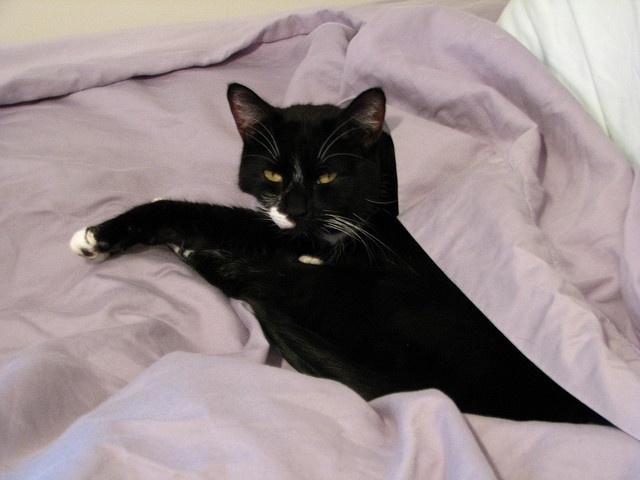Describe the objects in this image and their specific colors. I can see bed in darkgray and lightgray tones and cat in darkgray, black, gray, and darkgreen tones in this image. 